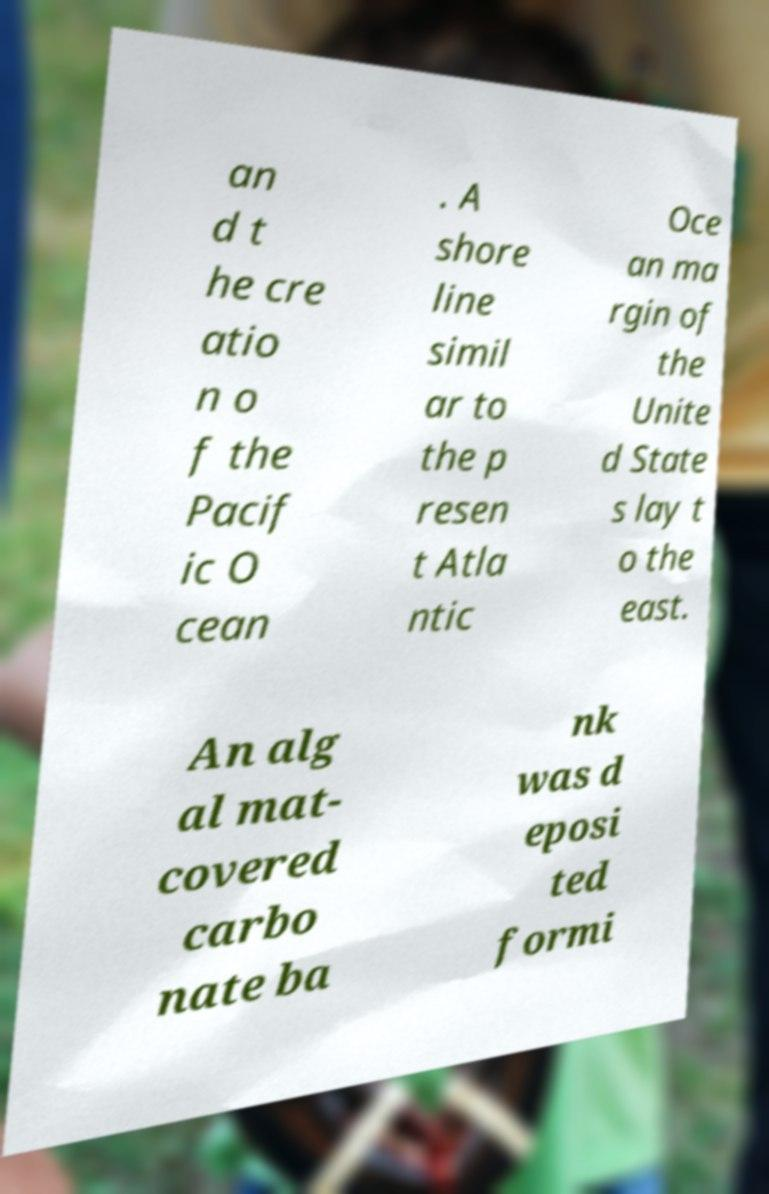Could you assist in decoding the text presented in this image and type it out clearly? an d t he cre atio n o f the Pacif ic O cean . A shore line simil ar to the p resen t Atla ntic Oce an ma rgin of the Unite d State s lay t o the east. An alg al mat- covered carbo nate ba nk was d eposi ted formi 